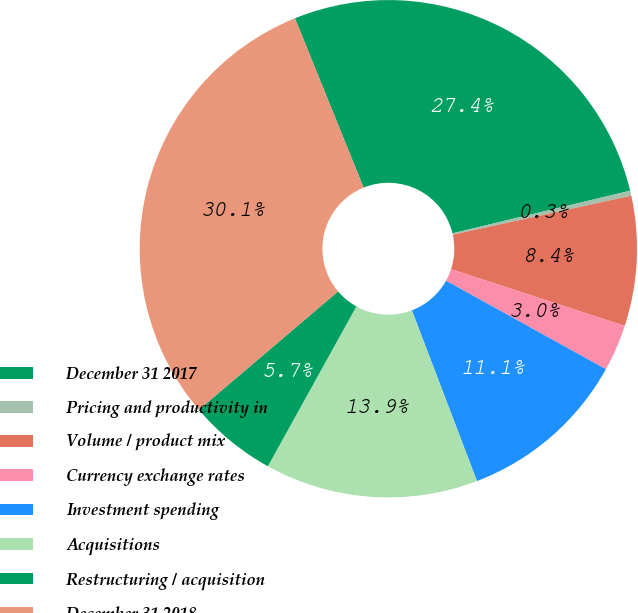Convert chart. <chart><loc_0><loc_0><loc_500><loc_500><pie_chart><fcel>December 31 2017<fcel>Pricing and productivity in<fcel>Volume / product mix<fcel>Currency exchange rates<fcel>Investment spending<fcel>Acquisitions<fcel>Restructuring / acquisition<fcel>December 31 2018<nl><fcel>27.38%<fcel>0.33%<fcel>8.44%<fcel>3.03%<fcel>11.15%<fcel>13.85%<fcel>5.74%<fcel>30.08%<nl></chart> 